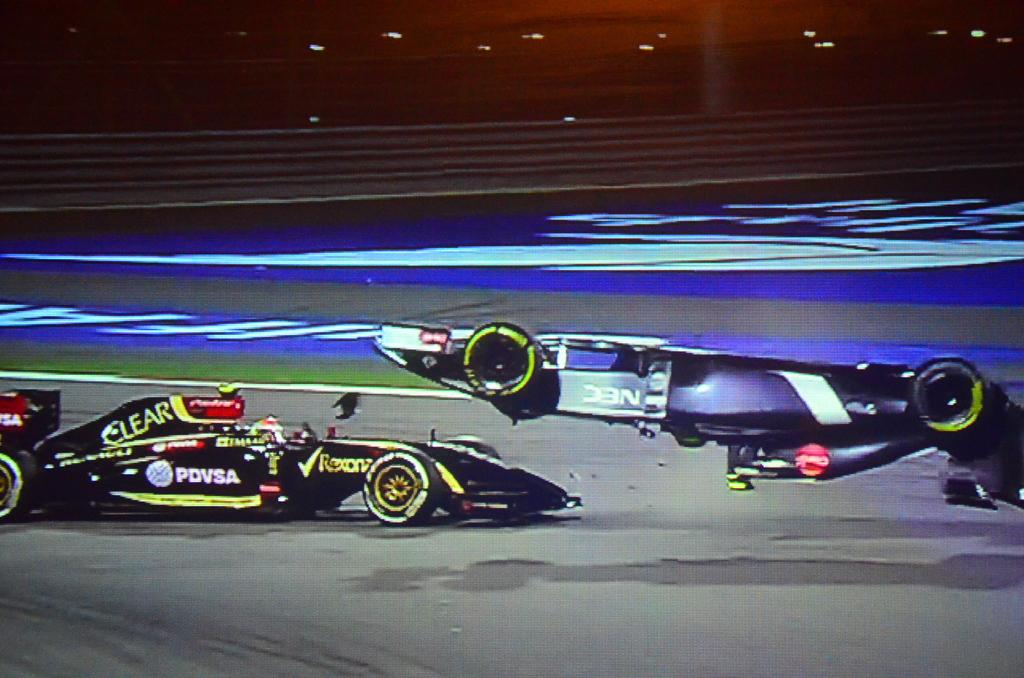Provide a one-sentence caption for the provided image. One of the two race cars is black and has the word Clear on it. 